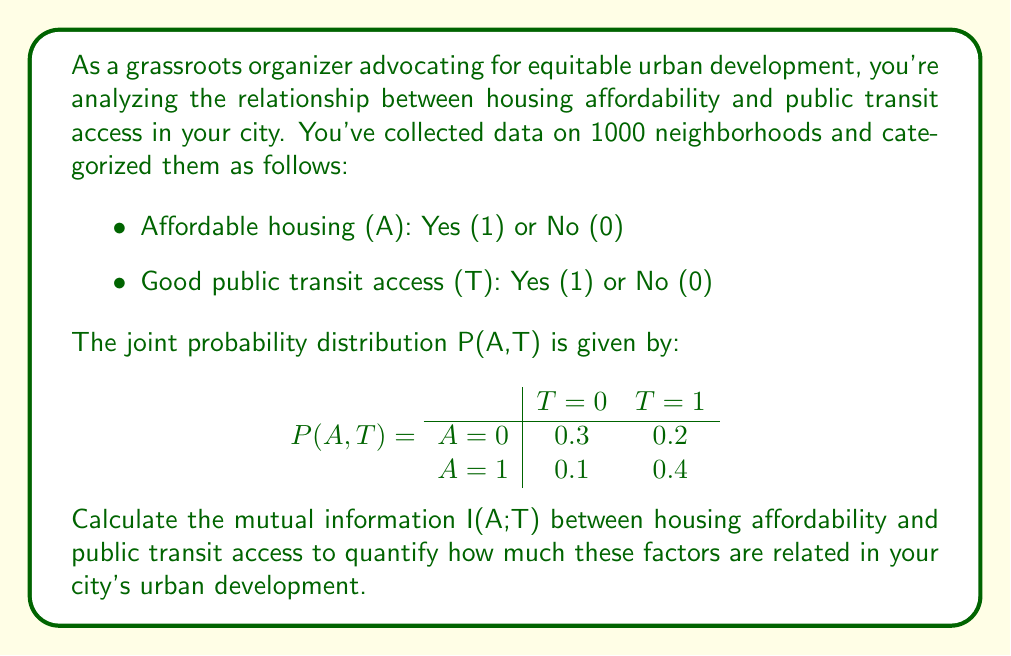Can you solve this math problem? To calculate the mutual information I(A;T), we'll follow these steps:

1. Calculate the marginal probabilities P(A) and P(T)
2. Calculate the entropy of A, H(A)
3. Calculate the conditional entropy of A given T, H(A|T)
4. Calculate I(A;T) = H(A) - H(A|T)

Step 1: Marginal probabilities

P(A=0) = 0.3 + 0.2 = 0.5
P(A=1) = 0.1 + 0.4 = 0.5
P(T=0) = 0.3 + 0.1 = 0.4
P(T=1) = 0.2 + 0.4 = 0.6

Step 2: Entropy of A

$$H(A) = -\sum_{a} P(A=a) \log_2 P(A=a)$$
$$H(A) = -[0.5 \log_2 0.5 + 0.5 \log_2 0.5] = 1 \text{ bit}$$

Step 3: Conditional entropy of A given T

$$H(A|T) = -\sum_{t} P(T=t) \sum_{a} P(A=a|T=t) \log_2 P(A=a|T=t)$$

For T=0:
P(A=0|T=0) = 0.3 / 0.4 = 0.75
P(A=1|T=0) = 0.1 / 0.4 = 0.25

For T=1:
P(A=0|T=1) = 0.2 / 0.6 = 0.33
P(A=1|T=1) = 0.4 / 0.6 = 0.67

$$H(A|T) = -[0.4 (0.75 \log_2 0.75 + 0.25 \log_2 0.25) + 0.6 (0.33 \log_2 0.33 + 0.67 \log_2 0.67)]$$
$$H(A|T) \approx 0.8113 \text{ bits}$$

Step 4: Mutual Information

$$I(A;T) = H(A) - H(A|T)$$
$$I(A;T) = 1 - 0.8113 = 0.1887 \text{ bits}$$
Answer: The mutual information I(A;T) between housing affordability and public transit access is approximately 0.1887 bits. 